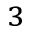<formula> <loc_0><loc_0><loc_500><loc_500>^ { 3 }</formula> 